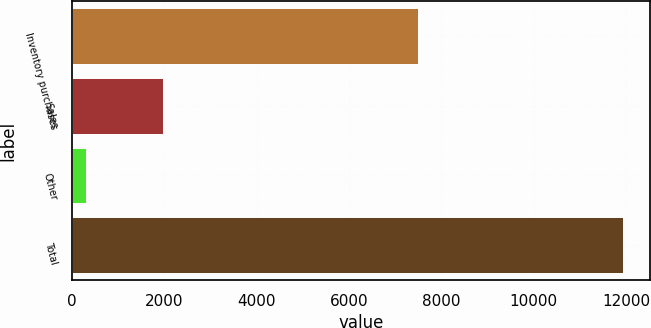Convert chart to OTSL. <chart><loc_0><loc_0><loc_500><loc_500><bar_chart><fcel>Inventory purchases<fcel>Sales<fcel>Other<fcel>Total<nl><fcel>7493<fcel>1965<fcel>302<fcel>11930<nl></chart> 